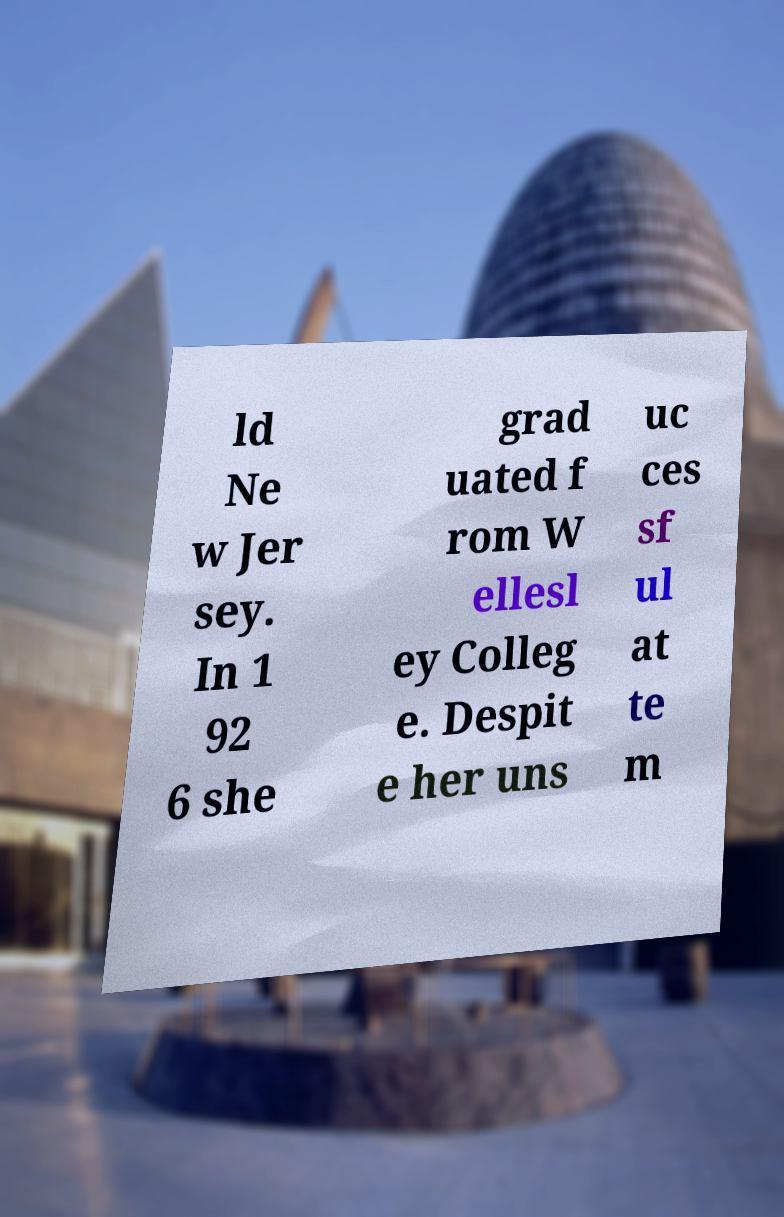Please identify and transcribe the text found in this image. ld Ne w Jer sey. In 1 92 6 she grad uated f rom W ellesl ey Colleg e. Despit e her uns uc ces sf ul at te m 